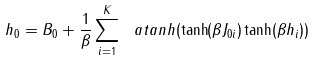<formula> <loc_0><loc_0><loc_500><loc_500>h _ { 0 } = B _ { 0 } + \frac { 1 } { \beta } \sum _ { i = 1 } ^ { K } \ a t a n h ( \tanh ( \beta J _ { 0 i } ) \tanh ( \beta h _ { i } ) )</formula> 